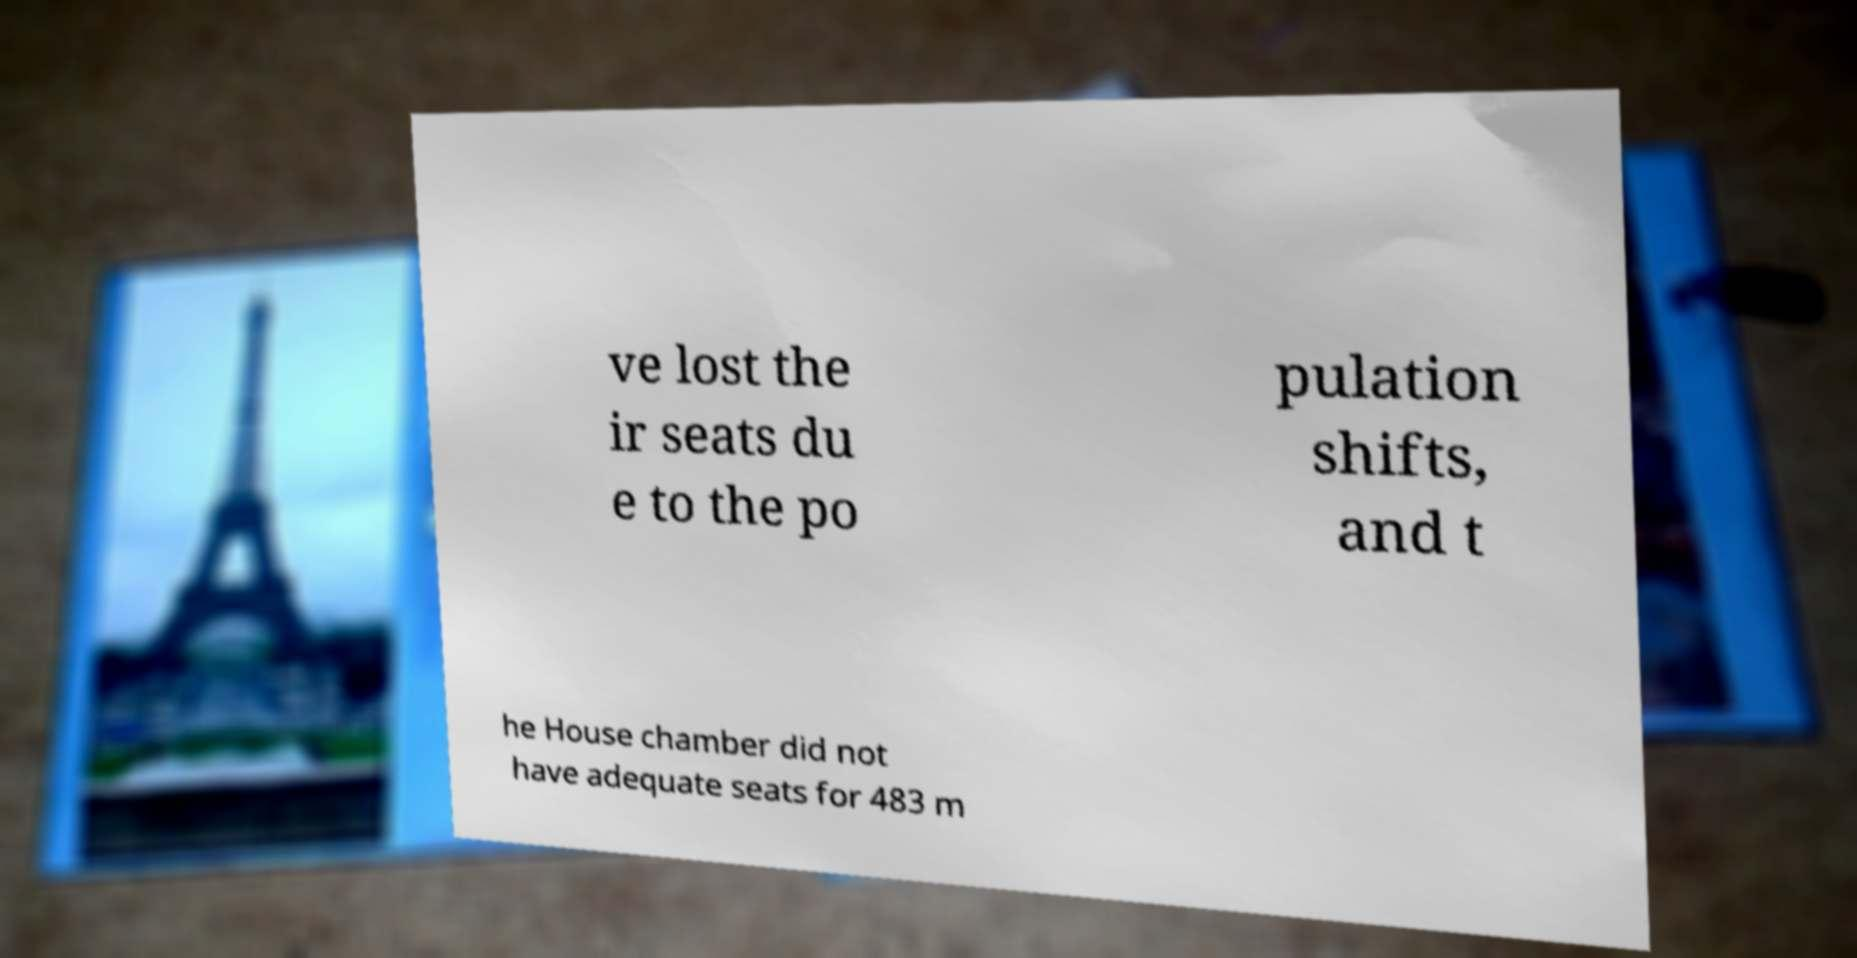What messages or text are displayed in this image? I need them in a readable, typed format. ve lost the ir seats du e to the po pulation shifts, and t he House chamber did not have adequate seats for 483 m 